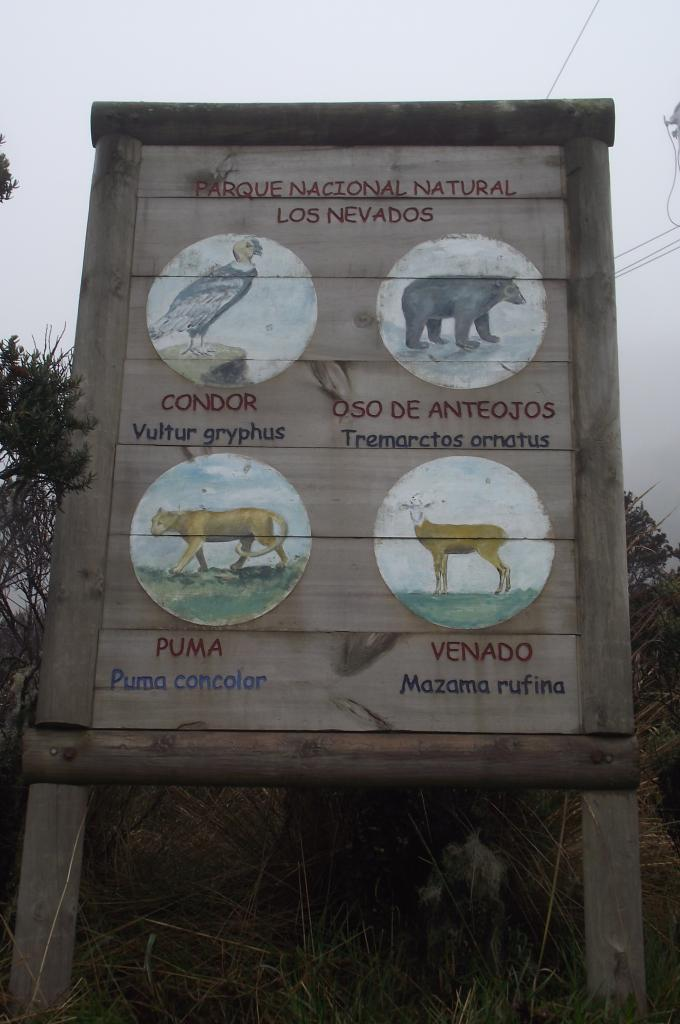What is the main object in the image? There is a wooden board with two poles in the image. What is depicted on the wooden board? The wooden board has a painting of animals on it. Are there any words on the wooden board? Yes, there is text on the wooden board. What type of natural environment can be seen in the image? There is grass visible in the image, and there are plants present as well. What else can be seen in the image? Electric wires are present in the image, and the sky is visible. How many icicles are hanging from the wooden board in the image? There are no icicles present in the image. What type of jam is being spread on the wooden board in the image? There is no jam present in the image. 